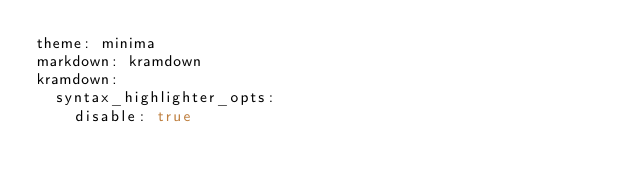Convert code to text. <code><loc_0><loc_0><loc_500><loc_500><_YAML_>theme: minima
markdown: kramdown
kramdown:
  syntax_highlighter_opts:
    disable: true
</code> 